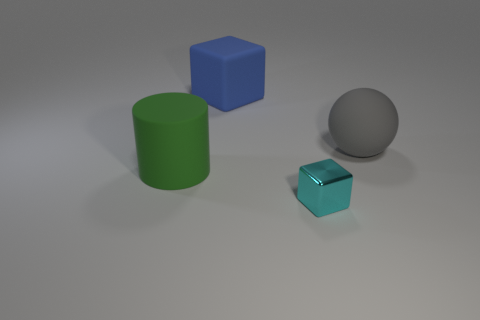Add 4 large green rubber things. How many objects exist? 8 Subtract all cyan cylinders. Subtract all cyan cubes. How many cylinders are left? 1 Subtract all blue balls. How many green blocks are left? 0 Subtract all large gray rubber things. Subtract all large cyan things. How many objects are left? 3 Add 4 tiny things. How many tiny things are left? 5 Add 3 large blue things. How many large blue things exist? 4 Subtract 1 gray spheres. How many objects are left? 3 